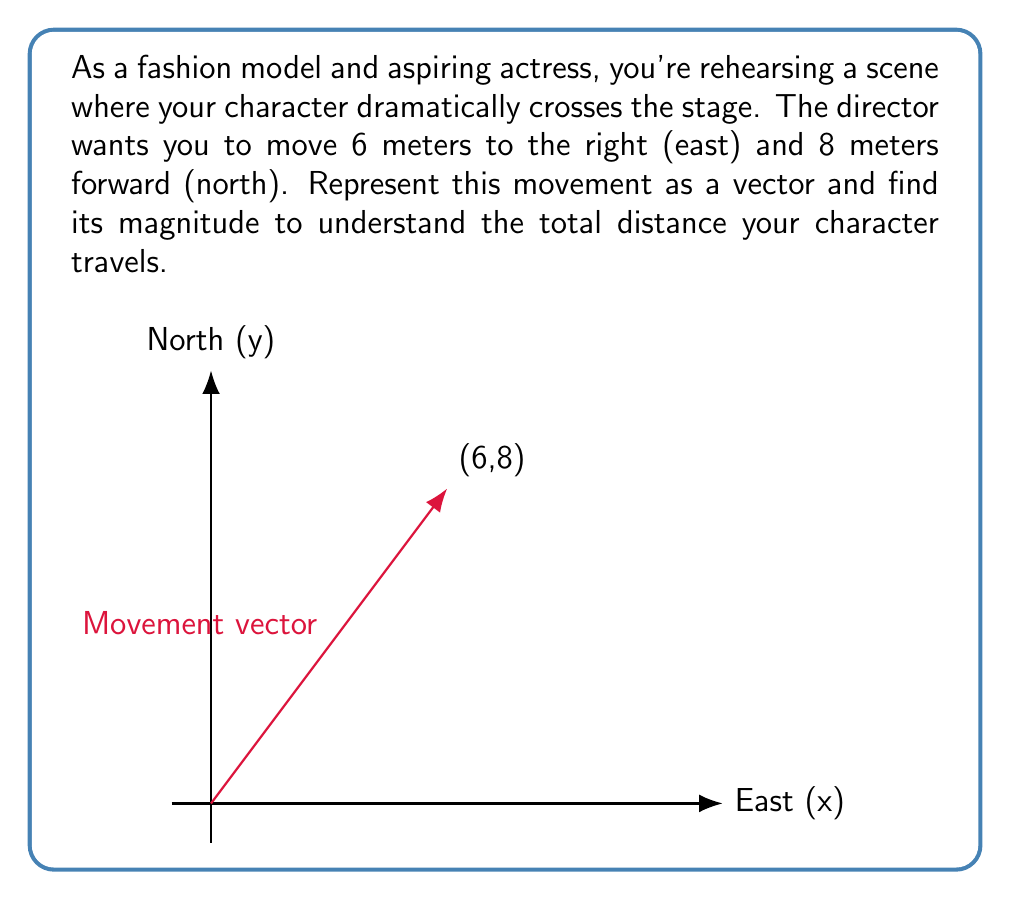Teach me how to tackle this problem. Let's approach this step-by-step:

1) The movement can be represented as a vector $\mathbf{v} = (6, 8)$, where:
   - 6 represents the movement to the right (east)
   - 8 represents the movement forward (north)

2) To find the magnitude of this vector, we use the formula:
   $$|\mathbf{v}| = \sqrt{x^2 + y^2}$$
   where $x$ and $y$ are the components of the vector.

3) Substituting our values:
   $$|\mathbf{v}| = \sqrt{6^2 + 8^2}$$

4) Simplify:
   $$|\mathbf{v}| = \sqrt{36 + 64}$$
   $$|\mathbf{v}| = \sqrt{100}$$

5) Calculate the square root:
   $$|\mathbf{v}| = 10$$

Therefore, the magnitude of the movement vector is 10 meters, which represents the total straight-line distance your character travels across the stage.
Answer: $10$ meters 